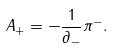<formula> <loc_0><loc_0><loc_500><loc_500>A _ { + } = - \frac { 1 } { \partial _ { - } } \pi ^ { - } .</formula> 